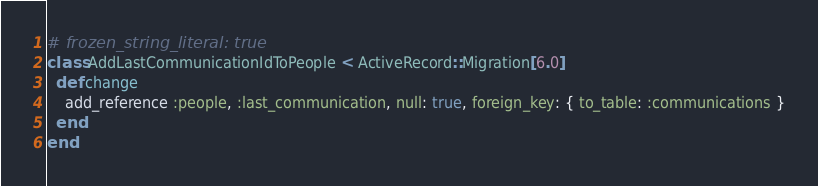<code> <loc_0><loc_0><loc_500><loc_500><_Ruby_># frozen_string_literal: true
class AddLastCommunicationIdToPeople < ActiveRecord::Migration[6.0]
  def change
    add_reference :people, :last_communication, null: true, foreign_key: { to_table: :communications }
  end
end
</code> 